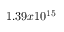Convert formula to latex. <formula><loc_0><loc_0><loc_500><loc_500>1 . 3 9 x 1 0 ^ { 1 5 }</formula> 